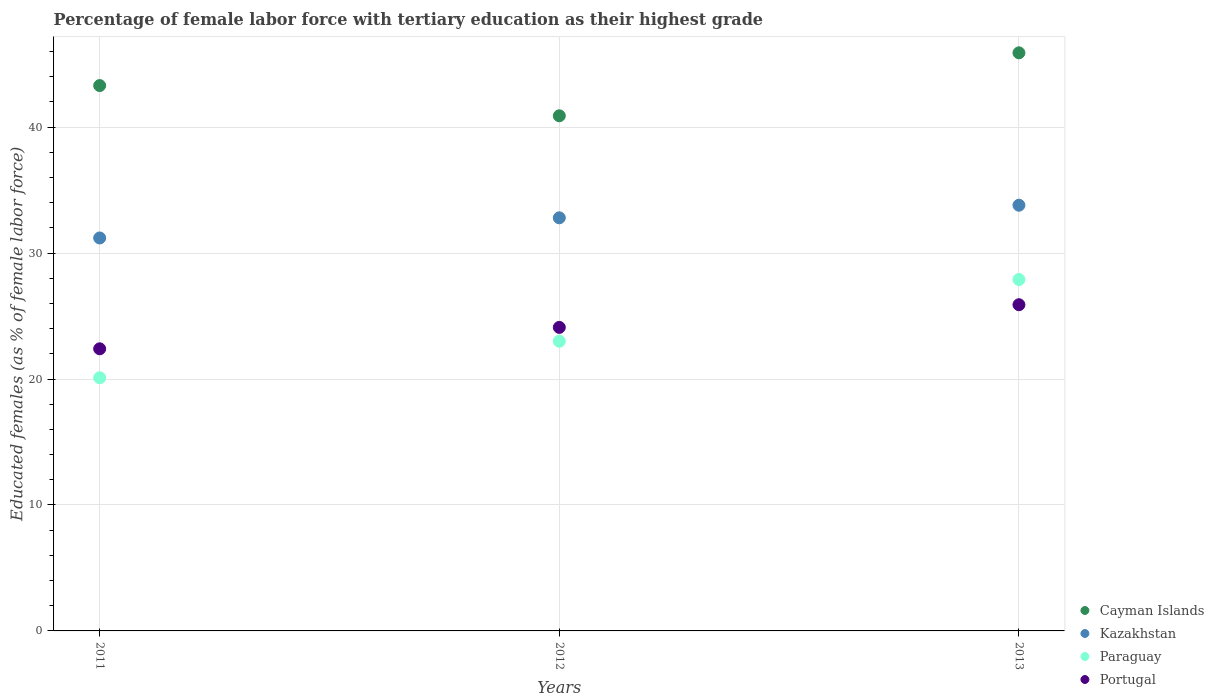What is the percentage of female labor force with tertiary education in Paraguay in 2011?
Provide a short and direct response. 20.1. Across all years, what is the maximum percentage of female labor force with tertiary education in Cayman Islands?
Provide a short and direct response. 45.9. Across all years, what is the minimum percentage of female labor force with tertiary education in Kazakhstan?
Offer a very short reply. 31.2. What is the total percentage of female labor force with tertiary education in Cayman Islands in the graph?
Provide a short and direct response. 130.1. What is the difference between the percentage of female labor force with tertiary education in Kazakhstan in 2011 and the percentage of female labor force with tertiary education in Cayman Islands in 2012?
Ensure brevity in your answer.  -9.7. What is the average percentage of female labor force with tertiary education in Cayman Islands per year?
Offer a very short reply. 43.37. In the year 2013, what is the difference between the percentage of female labor force with tertiary education in Portugal and percentage of female labor force with tertiary education in Kazakhstan?
Provide a short and direct response. -7.9. What is the ratio of the percentage of female labor force with tertiary education in Portugal in 2011 to that in 2013?
Provide a short and direct response. 0.86. Is the difference between the percentage of female labor force with tertiary education in Portugal in 2012 and 2013 greater than the difference between the percentage of female labor force with tertiary education in Kazakhstan in 2012 and 2013?
Keep it short and to the point. No. What is the difference between the highest and the second highest percentage of female labor force with tertiary education in Portugal?
Make the answer very short. 1.8. What is the difference between the highest and the lowest percentage of female labor force with tertiary education in Paraguay?
Your answer should be very brief. 7.8. In how many years, is the percentage of female labor force with tertiary education in Portugal greater than the average percentage of female labor force with tertiary education in Portugal taken over all years?
Give a very brief answer. 1. Is it the case that in every year, the sum of the percentage of female labor force with tertiary education in Portugal and percentage of female labor force with tertiary education in Kazakhstan  is greater than the percentage of female labor force with tertiary education in Paraguay?
Offer a terse response. Yes. Is the percentage of female labor force with tertiary education in Paraguay strictly less than the percentage of female labor force with tertiary education in Cayman Islands over the years?
Provide a short and direct response. Yes. Does the graph contain any zero values?
Keep it short and to the point. No. Does the graph contain grids?
Provide a succinct answer. Yes. How many legend labels are there?
Ensure brevity in your answer.  4. What is the title of the graph?
Keep it short and to the point. Percentage of female labor force with tertiary education as their highest grade. What is the label or title of the X-axis?
Offer a terse response. Years. What is the label or title of the Y-axis?
Give a very brief answer. Educated females (as % of female labor force). What is the Educated females (as % of female labor force) in Cayman Islands in 2011?
Provide a succinct answer. 43.3. What is the Educated females (as % of female labor force) in Kazakhstan in 2011?
Your response must be concise. 31.2. What is the Educated females (as % of female labor force) in Paraguay in 2011?
Ensure brevity in your answer.  20.1. What is the Educated females (as % of female labor force) of Portugal in 2011?
Your answer should be very brief. 22.4. What is the Educated females (as % of female labor force) of Cayman Islands in 2012?
Provide a succinct answer. 40.9. What is the Educated females (as % of female labor force) in Kazakhstan in 2012?
Your response must be concise. 32.8. What is the Educated females (as % of female labor force) in Portugal in 2012?
Keep it short and to the point. 24.1. What is the Educated females (as % of female labor force) in Cayman Islands in 2013?
Offer a very short reply. 45.9. What is the Educated females (as % of female labor force) of Kazakhstan in 2013?
Offer a very short reply. 33.8. What is the Educated females (as % of female labor force) in Paraguay in 2013?
Provide a short and direct response. 27.9. What is the Educated females (as % of female labor force) of Portugal in 2013?
Offer a very short reply. 25.9. Across all years, what is the maximum Educated females (as % of female labor force) in Cayman Islands?
Provide a short and direct response. 45.9. Across all years, what is the maximum Educated females (as % of female labor force) in Kazakhstan?
Provide a succinct answer. 33.8. Across all years, what is the maximum Educated females (as % of female labor force) of Paraguay?
Provide a succinct answer. 27.9. Across all years, what is the maximum Educated females (as % of female labor force) of Portugal?
Give a very brief answer. 25.9. Across all years, what is the minimum Educated females (as % of female labor force) in Cayman Islands?
Provide a short and direct response. 40.9. Across all years, what is the minimum Educated females (as % of female labor force) in Kazakhstan?
Keep it short and to the point. 31.2. Across all years, what is the minimum Educated females (as % of female labor force) in Paraguay?
Ensure brevity in your answer.  20.1. Across all years, what is the minimum Educated females (as % of female labor force) in Portugal?
Your answer should be compact. 22.4. What is the total Educated females (as % of female labor force) of Cayman Islands in the graph?
Offer a very short reply. 130.1. What is the total Educated females (as % of female labor force) in Kazakhstan in the graph?
Offer a terse response. 97.8. What is the total Educated females (as % of female labor force) of Paraguay in the graph?
Keep it short and to the point. 71. What is the total Educated females (as % of female labor force) in Portugal in the graph?
Provide a short and direct response. 72.4. What is the difference between the Educated females (as % of female labor force) of Cayman Islands in 2011 and that in 2012?
Make the answer very short. 2.4. What is the difference between the Educated females (as % of female labor force) in Kazakhstan in 2011 and that in 2012?
Keep it short and to the point. -1.6. What is the difference between the Educated females (as % of female labor force) in Paraguay in 2011 and that in 2012?
Your answer should be very brief. -2.9. What is the difference between the Educated females (as % of female labor force) in Portugal in 2011 and that in 2012?
Your answer should be compact. -1.7. What is the difference between the Educated females (as % of female labor force) in Cayman Islands in 2011 and that in 2013?
Offer a very short reply. -2.6. What is the difference between the Educated females (as % of female labor force) of Kazakhstan in 2011 and that in 2013?
Your answer should be compact. -2.6. What is the difference between the Educated females (as % of female labor force) in Paraguay in 2011 and that in 2013?
Your answer should be very brief. -7.8. What is the difference between the Educated females (as % of female labor force) of Portugal in 2011 and that in 2013?
Offer a terse response. -3.5. What is the difference between the Educated females (as % of female labor force) in Cayman Islands in 2011 and the Educated females (as % of female labor force) in Paraguay in 2012?
Provide a short and direct response. 20.3. What is the difference between the Educated females (as % of female labor force) in Kazakhstan in 2011 and the Educated females (as % of female labor force) in Portugal in 2013?
Give a very brief answer. 5.3. What is the difference between the Educated females (as % of female labor force) of Kazakhstan in 2012 and the Educated females (as % of female labor force) of Paraguay in 2013?
Ensure brevity in your answer.  4.9. What is the difference between the Educated females (as % of female labor force) in Paraguay in 2012 and the Educated females (as % of female labor force) in Portugal in 2013?
Give a very brief answer. -2.9. What is the average Educated females (as % of female labor force) in Cayman Islands per year?
Your answer should be compact. 43.37. What is the average Educated females (as % of female labor force) in Kazakhstan per year?
Provide a short and direct response. 32.6. What is the average Educated females (as % of female labor force) of Paraguay per year?
Your response must be concise. 23.67. What is the average Educated females (as % of female labor force) of Portugal per year?
Offer a very short reply. 24.13. In the year 2011, what is the difference between the Educated females (as % of female labor force) of Cayman Islands and Educated females (as % of female labor force) of Paraguay?
Ensure brevity in your answer.  23.2. In the year 2011, what is the difference between the Educated females (as % of female labor force) in Cayman Islands and Educated females (as % of female labor force) in Portugal?
Provide a short and direct response. 20.9. In the year 2011, what is the difference between the Educated females (as % of female labor force) in Kazakhstan and Educated females (as % of female labor force) in Portugal?
Keep it short and to the point. 8.8. In the year 2011, what is the difference between the Educated females (as % of female labor force) in Paraguay and Educated females (as % of female labor force) in Portugal?
Make the answer very short. -2.3. In the year 2012, what is the difference between the Educated females (as % of female labor force) in Kazakhstan and Educated females (as % of female labor force) in Paraguay?
Give a very brief answer. 9.8. In the year 2012, what is the difference between the Educated females (as % of female labor force) in Kazakhstan and Educated females (as % of female labor force) in Portugal?
Your answer should be compact. 8.7. In the year 2012, what is the difference between the Educated females (as % of female labor force) of Paraguay and Educated females (as % of female labor force) of Portugal?
Ensure brevity in your answer.  -1.1. In the year 2013, what is the difference between the Educated females (as % of female labor force) of Cayman Islands and Educated females (as % of female labor force) of Kazakhstan?
Your answer should be compact. 12.1. In the year 2013, what is the difference between the Educated females (as % of female labor force) in Cayman Islands and Educated females (as % of female labor force) in Paraguay?
Provide a succinct answer. 18. In the year 2013, what is the difference between the Educated females (as % of female labor force) in Cayman Islands and Educated females (as % of female labor force) in Portugal?
Your response must be concise. 20. What is the ratio of the Educated females (as % of female labor force) of Cayman Islands in 2011 to that in 2012?
Keep it short and to the point. 1.06. What is the ratio of the Educated females (as % of female labor force) in Kazakhstan in 2011 to that in 2012?
Give a very brief answer. 0.95. What is the ratio of the Educated females (as % of female labor force) of Paraguay in 2011 to that in 2012?
Keep it short and to the point. 0.87. What is the ratio of the Educated females (as % of female labor force) of Portugal in 2011 to that in 2012?
Your answer should be compact. 0.93. What is the ratio of the Educated females (as % of female labor force) in Cayman Islands in 2011 to that in 2013?
Provide a short and direct response. 0.94. What is the ratio of the Educated females (as % of female labor force) in Paraguay in 2011 to that in 2013?
Your response must be concise. 0.72. What is the ratio of the Educated females (as % of female labor force) of Portugal in 2011 to that in 2013?
Offer a very short reply. 0.86. What is the ratio of the Educated females (as % of female labor force) in Cayman Islands in 2012 to that in 2013?
Provide a short and direct response. 0.89. What is the ratio of the Educated females (as % of female labor force) of Kazakhstan in 2012 to that in 2013?
Offer a very short reply. 0.97. What is the ratio of the Educated females (as % of female labor force) of Paraguay in 2012 to that in 2013?
Your answer should be very brief. 0.82. What is the ratio of the Educated females (as % of female labor force) in Portugal in 2012 to that in 2013?
Your response must be concise. 0.93. What is the difference between the highest and the second highest Educated females (as % of female labor force) of Cayman Islands?
Offer a very short reply. 2.6. What is the difference between the highest and the second highest Educated females (as % of female labor force) of Paraguay?
Your response must be concise. 4.9. What is the difference between the highest and the lowest Educated females (as % of female labor force) of Portugal?
Your answer should be compact. 3.5. 